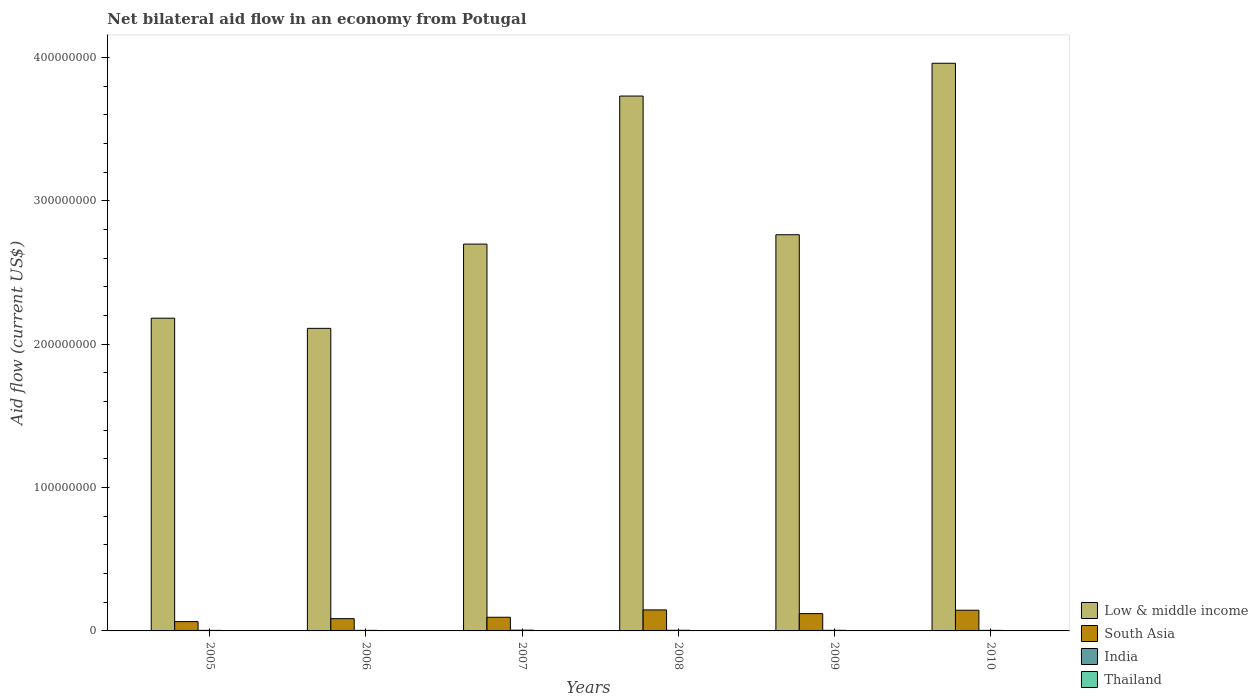How many bars are there on the 3rd tick from the left?
Ensure brevity in your answer.  4. Across all years, what is the maximum net bilateral aid flow in Low & middle income?
Your answer should be compact. 3.96e+08. In which year was the net bilateral aid flow in Low & middle income minimum?
Provide a succinct answer. 2006. What is the total net bilateral aid flow in Thailand in the graph?
Ensure brevity in your answer.  5.20e+05. What is the difference between the net bilateral aid flow in Thailand in 2005 and that in 2007?
Provide a short and direct response. 2.00e+04. What is the difference between the net bilateral aid flow in Thailand in 2010 and the net bilateral aid flow in India in 2006?
Give a very brief answer. -3.50e+05. What is the average net bilateral aid flow in Thailand per year?
Keep it short and to the point. 8.67e+04. In the year 2010, what is the difference between the net bilateral aid flow in South Asia and net bilateral aid flow in Thailand?
Give a very brief answer. 1.44e+07. What is the ratio of the net bilateral aid flow in India in 2007 to that in 2009?
Provide a short and direct response. 1.24. Is the net bilateral aid flow in Low & middle income in 2008 less than that in 2010?
Your answer should be very brief. Yes. What is the difference between the highest and the second highest net bilateral aid flow in India?
Make the answer very short. 8.00e+04. What is the difference between the highest and the lowest net bilateral aid flow in Low & middle income?
Keep it short and to the point. 1.85e+08. In how many years, is the net bilateral aid flow in South Asia greater than the average net bilateral aid flow in South Asia taken over all years?
Make the answer very short. 3. What does the 4th bar from the left in 2009 represents?
Your response must be concise. Thailand. What does the 1st bar from the right in 2007 represents?
Keep it short and to the point. Thailand. How many bars are there?
Your answer should be compact. 24. How many years are there in the graph?
Offer a very short reply. 6. What is the difference between two consecutive major ticks on the Y-axis?
Provide a short and direct response. 1.00e+08. Where does the legend appear in the graph?
Offer a terse response. Bottom right. How are the legend labels stacked?
Give a very brief answer. Vertical. What is the title of the graph?
Your answer should be very brief. Net bilateral aid flow in an economy from Potugal. What is the label or title of the X-axis?
Give a very brief answer. Years. What is the label or title of the Y-axis?
Give a very brief answer. Aid flow (current US$). What is the Aid flow (current US$) in Low & middle income in 2005?
Provide a succinct answer. 2.18e+08. What is the Aid flow (current US$) of South Asia in 2005?
Ensure brevity in your answer.  6.50e+06. What is the Aid flow (current US$) in India in 2005?
Provide a short and direct response. 3.90e+05. What is the Aid flow (current US$) of Thailand in 2005?
Keep it short and to the point. 6.00e+04. What is the Aid flow (current US$) of Low & middle income in 2006?
Offer a very short reply. 2.11e+08. What is the Aid flow (current US$) in South Asia in 2006?
Give a very brief answer. 8.56e+06. What is the Aid flow (current US$) of Low & middle income in 2007?
Offer a very short reply. 2.70e+08. What is the Aid flow (current US$) of South Asia in 2007?
Provide a short and direct response. 9.53e+06. What is the Aid flow (current US$) of India in 2007?
Offer a terse response. 5.20e+05. What is the Aid flow (current US$) of Low & middle income in 2008?
Offer a very short reply. 3.73e+08. What is the Aid flow (current US$) of South Asia in 2008?
Provide a succinct answer. 1.46e+07. What is the Aid flow (current US$) of Low & middle income in 2009?
Make the answer very short. 2.76e+08. What is the Aid flow (current US$) in South Asia in 2009?
Provide a short and direct response. 1.21e+07. What is the Aid flow (current US$) of India in 2009?
Give a very brief answer. 4.20e+05. What is the Aid flow (current US$) in Thailand in 2009?
Provide a succinct answer. 7.00e+04. What is the Aid flow (current US$) of Low & middle income in 2010?
Offer a very short reply. 3.96e+08. What is the Aid flow (current US$) of South Asia in 2010?
Give a very brief answer. 1.44e+07. Across all years, what is the maximum Aid flow (current US$) of Low & middle income?
Make the answer very short. 3.96e+08. Across all years, what is the maximum Aid flow (current US$) of South Asia?
Make the answer very short. 1.46e+07. Across all years, what is the maximum Aid flow (current US$) of India?
Make the answer very short. 5.20e+05. Across all years, what is the maximum Aid flow (current US$) of Thailand?
Offer a terse response. 2.20e+05. Across all years, what is the minimum Aid flow (current US$) of Low & middle income?
Make the answer very short. 2.11e+08. Across all years, what is the minimum Aid flow (current US$) in South Asia?
Offer a terse response. 6.50e+06. Across all years, what is the minimum Aid flow (current US$) of India?
Provide a short and direct response. 3.90e+05. What is the total Aid flow (current US$) in Low & middle income in the graph?
Offer a terse response. 1.74e+09. What is the total Aid flow (current US$) in South Asia in the graph?
Keep it short and to the point. 6.57e+07. What is the total Aid flow (current US$) of India in the graph?
Keep it short and to the point. 2.55e+06. What is the total Aid flow (current US$) of Thailand in the graph?
Your answer should be very brief. 5.20e+05. What is the difference between the Aid flow (current US$) of Low & middle income in 2005 and that in 2006?
Provide a succinct answer. 7.09e+06. What is the difference between the Aid flow (current US$) in South Asia in 2005 and that in 2006?
Your response must be concise. -2.06e+06. What is the difference between the Aid flow (current US$) of India in 2005 and that in 2006?
Your answer should be very brief. 0. What is the difference between the Aid flow (current US$) of Low & middle income in 2005 and that in 2007?
Provide a short and direct response. -5.17e+07. What is the difference between the Aid flow (current US$) in South Asia in 2005 and that in 2007?
Your answer should be compact. -3.03e+06. What is the difference between the Aid flow (current US$) in India in 2005 and that in 2007?
Offer a very short reply. -1.30e+05. What is the difference between the Aid flow (current US$) of Low & middle income in 2005 and that in 2008?
Your response must be concise. -1.55e+08. What is the difference between the Aid flow (current US$) in South Asia in 2005 and that in 2008?
Keep it short and to the point. -8.15e+06. What is the difference between the Aid flow (current US$) in India in 2005 and that in 2008?
Your answer should be very brief. -5.00e+04. What is the difference between the Aid flow (current US$) in Low & middle income in 2005 and that in 2009?
Your response must be concise. -5.82e+07. What is the difference between the Aid flow (current US$) in South Asia in 2005 and that in 2009?
Make the answer very short. -5.56e+06. What is the difference between the Aid flow (current US$) of India in 2005 and that in 2009?
Offer a terse response. -3.00e+04. What is the difference between the Aid flow (current US$) in Low & middle income in 2005 and that in 2010?
Your answer should be very brief. -1.78e+08. What is the difference between the Aid flow (current US$) of South Asia in 2005 and that in 2010?
Your answer should be very brief. -7.94e+06. What is the difference between the Aid flow (current US$) in India in 2005 and that in 2010?
Your answer should be very brief. 0. What is the difference between the Aid flow (current US$) in Thailand in 2005 and that in 2010?
Offer a very short reply. 2.00e+04. What is the difference between the Aid flow (current US$) in Low & middle income in 2006 and that in 2007?
Your answer should be compact. -5.88e+07. What is the difference between the Aid flow (current US$) of South Asia in 2006 and that in 2007?
Your answer should be compact. -9.70e+05. What is the difference between the Aid flow (current US$) of Thailand in 2006 and that in 2007?
Provide a succinct answer. 1.80e+05. What is the difference between the Aid flow (current US$) of Low & middle income in 2006 and that in 2008?
Keep it short and to the point. -1.62e+08. What is the difference between the Aid flow (current US$) of South Asia in 2006 and that in 2008?
Your response must be concise. -6.09e+06. What is the difference between the Aid flow (current US$) of Thailand in 2006 and that in 2008?
Your response must be concise. 1.30e+05. What is the difference between the Aid flow (current US$) in Low & middle income in 2006 and that in 2009?
Offer a terse response. -6.53e+07. What is the difference between the Aid flow (current US$) of South Asia in 2006 and that in 2009?
Offer a terse response. -3.50e+06. What is the difference between the Aid flow (current US$) in Low & middle income in 2006 and that in 2010?
Your answer should be compact. -1.85e+08. What is the difference between the Aid flow (current US$) of South Asia in 2006 and that in 2010?
Provide a succinct answer. -5.88e+06. What is the difference between the Aid flow (current US$) in India in 2006 and that in 2010?
Offer a terse response. 0. What is the difference between the Aid flow (current US$) of Thailand in 2006 and that in 2010?
Ensure brevity in your answer.  1.80e+05. What is the difference between the Aid flow (current US$) of Low & middle income in 2007 and that in 2008?
Keep it short and to the point. -1.03e+08. What is the difference between the Aid flow (current US$) in South Asia in 2007 and that in 2008?
Provide a short and direct response. -5.12e+06. What is the difference between the Aid flow (current US$) in India in 2007 and that in 2008?
Make the answer very short. 8.00e+04. What is the difference between the Aid flow (current US$) in Low & middle income in 2007 and that in 2009?
Ensure brevity in your answer.  -6.52e+06. What is the difference between the Aid flow (current US$) of South Asia in 2007 and that in 2009?
Provide a succinct answer. -2.53e+06. What is the difference between the Aid flow (current US$) of Thailand in 2007 and that in 2009?
Make the answer very short. -3.00e+04. What is the difference between the Aid flow (current US$) of Low & middle income in 2007 and that in 2010?
Provide a succinct answer. -1.26e+08. What is the difference between the Aid flow (current US$) of South Asia in 2007 and that in 2010?
Provide a short and direct response. -4.91e+06. What is the difference between the Aid flow (current US$) in Low & middle income in 2008 and that in 2009?
Your answer should be compact. 9.67e+07. What is the difference between the Aid flow (current US$) in South Asia in 2008 and that in 2009?
Provide a succinct answer. 2.59e+06. What is the difference between the Aid flow (current US$) in Thailand in 2008 and that in 2009?
Ensure brevity in your answer.  2.00e+04. What is the difference between the Aid flow (current US$) in Low & middle income in 2008 and that in 2010?
Provide a succinct answer. -2.29e+07. What is the difference between the Aid flow (current US$) in South Asia in 2008 and that in 2010?
Offer a very short reply. 2.10e+05. What is the difference between the Aid flow (current US$) in India in 2008 and that in 2010?
Ensure brevity in your answer.  5.00e+04. What is the difference between the Aid flow (current US$) in Low & middle income in 2009 and that in 2010?
Offer a terse response. -1.20e+08. What is the difference between the Aid flow (current US$) of South Asia in 2009 and that in 2010?
Your answer should be very brief. -2.38e+06. What is the difference between the Aid flow (current US$) of India in 2009 and that in 2010?
Make the answer very short. 3.00e+04. What is the difference between the Aid flow (current US$) in Thailand in 2009 and that in 2010?
Give a very brief answer. 3.00e+04. What is the difference between the Aid flow (current US$) in Low & middle income in 2005 and the Aid flow (current US$) in South Asia in 2006?
Your response must be concise. 2.10e+08. What is the difference between the Aid flow (current US$) in Low & middle income in 2005 and the Aid flow (current US$) in India in 2006?
Your answer should be compact. 2.18e+08. What is the difference between the Aid flow (current US$) of Low & middle income in 2005 and the Aid flow (current US$) of Thailand in 2006?
Offer a terse response. 2.18e+08. What is the difference between the Aid flow (current US$) in South Asia in 2005 and the Aid flow (current US$) in India in 2006?
Make the answer very short. 6.11e+06. What is the difference between the Aid flow (current US$) in South Asia in 2005 and the Aid flow (current US$) in Thailand in 2006?
Your answer should be compact. 6.28e+06. What is the difference between the Aid flow (current US$) of India in 2005 and the Aid flow (current US$) of Thailand in 2006?
Offer a terse response. 1.70e+05. What is the difference between the Aid flow (current US$) of Low & middle income in 2005 and the Aid flow (current US$) of South Asia in 2007?
Give a very brief answer. 2.09e+08. What is the difference between the Aid flow (current US$) in Low & middle income in 2005 and the Aid flow (current US$) in India in 2007?
Provide a short and direct response. 2.18e+08. What is the difference between the Aid flow (current US$) in Low & middle income in 2005 and the Aid flow (current US$) in Thailand in 2007?
Offer a terse response. 2.18e+08. What is the difference between the Aid flow (current US$) in South Asia in 2005 and the Aid flow (current US$) in India in 2007?
Your response must be concise. 5.98e+06. What is the difference between the Aid flow (current US$) of South Asia in 2005 and the Aid flow (current US$) of Thailand in 2007?
Provide a succinct answer. 6.46e+06. What is the difference between the Aid flow (current US$) in India in 2005 and the Aid flow (current US$) in Thailand in 2007?
Give a very brief answer. 3.50e+05. What is the difference between the Aid flow (current US$) of Low & middle income in 2005 and the Aid flow (current US$) of South Asia in 2008?
Provide a succinct answer. 2.03e+08. What is the difference between the Aid flow (current US$) in Low & middle income in 2005 and the Aid flow (current US$) in India in 2008?
Provide a short and direct response. 2.18e+08. What is the difference between the Aid flow (current US$) in Low & middle income in 2005 and the Aid flow (current US$) in Thailand in 2008?
Keep it short and to the point. 2.18e+08. What is the difference between the Aid flow (current US$) of South Asia in 2005 and the Aid flow (current US$) of India in 2008?
Ensure brevity in your answer.  6.06e+06. What is the difference between the Aid flow (current US$) of South Asia in 2005 and the Aid flow (current US$) of Thailand in 2008?
Offer a very short reply. 6.41e+06. What is the difference between the Aid flow (current US$) in Low & middle income in 2005 and the Aid flow (current US$) in South Asia in 2009?
Provide a succinct answer. 2.06e+08. What is the difference between the Aid flow (current US$) in Low & middle income in 2005 and the Aid flow (current US$) in India in 2009?
Give a very brief answer. 2.18e+08. What is the difference between the Aid flow (current US$) in Low & middle income in 2005 and the Aid flow (current US$) in Thailand in 2009?
Provide a short and direct response. 2.18e+08. What is the difference between the Aid flow (current US$) in South Asia in 2005 and the Aid flow (current US$) in India in 2009?
Provide a succinct answer. 6.08e+06. What is the difference between the Aid flow (current US$) of South Asia in 2005 and the Aid flow (current US$) of Thailand in 2009?
Provide a short and direct response. 6.43e+06. What is the difference between the Aid flow (current US$) in India in 2005 and the Aid flow (current US$) in Thailand in 2009?
Your response must be concise. 3.20e+05. What is the difference between the Aid flow (current US$) in Low & middle income in 2005 and the Aid flow (current US$) in South Asia in 2010?
Keep it short and to the point. 2.04e+08. What is the difference between the Aid flow (current US$) of Low & middle income in 2005 and the Aid flow (current US$) of India in 2010?
Provide a short and direct response. 2.18e+08. What is the difference between the Aid flow (current US$) in Low & middle income in 2005 and the Aid flow (current US$) in Thailand in 2010?
Keep it short and to the point. 2.18e+08. What is the difference between the Aid flow (current US$) in South Asia in 2005 and the Aid flow (current US$) in India in 2010?
Ensure brevity in your answer.  6.11e+06. What is the difference between the Aid flow (current US$) in South Asia in 2005 and the Aid flow (current US$) in Thailand in 2010?
Provide a succinct answer. 6.46e+06. What is the difference between the Aid flow (current US$) in India in 2005 and the Aid flow (current US$) in Thailand in 2010?
Your answer should be very brief. 3.50e+05. What is the difference between the Aid flow (current US$) in Low & middle income in 2006 and the Aid flow (current US$) in South Asia in 2007?
Provide a short and direct response. 2.02e+08. What is the difference between the Aid flow (current US$) in Low & middle income in 2006 and the Aid flow (current US$) in India in 2007?
Give a very brief answer. 2.11e+08. What is the difference between the Aid flow (current US$) in Low & middle income in 2006 and the Aid flow (current US$) in Thailand in 2007?
Keep it short and to the point. 2.11e+08. What is the difference between the Aid flow (current US$) of South Asia in 2006 and the Aid flow (current US$) of India in 2007?
Your answer should be compact. 8.04e+06. What is the difference between the Aid flow (current US$) of South Asia in 2006 and the Aid flow (current US$) of Thailand in 2007?
Provide a short and direct response. 8.52e+06. What is the difference between the Aid flow (current US$) in Low & middle income in 2006 and the Aid flow (current US$) in South Asia in 2008?
Offer a terse response. 1.96e+08. What is the difference between the Aid flow (current US$) in Low & middle income in 2006 and the Aid flow (current US$) in India in 2008?
Offer a terse response. 2.11e+08. What is the difference between the Aid flow (current US$) of Low & middle income in 2006 and the Aid flow (current US$) of Thailand in 2008?
Your answer should be compact. 2.11e+08. What is the difference between the Aid flow (current US$) in South Asia in 2006 and the Aid flow (current US$) in India in 2008?
Offer a terse response. 8.12e+06. What is the difference between the Aid flow (current US$) in South Asia in 2006 and the Aid flow (current US$) in Thailand in 2008?
Your answer should be compact. 8.47e+06. What is the difference between the Aid flow (current US$) of Low & middle income in 2006 and the Aid flow (current US$) of South Asia in 2009?
Provide a short and direct response. 1.99e+08. What is the difference between the Aid flow (current US$) of Low & middle income in 2006 and the Aid flow (current US$) of India in 2009?
Ensure brevity in your answer.  2.11e+08. What is the difference between the Aid flow (current US$) in Low & middle income in 2006 and the Aid flow (current US$) in Thailand in 2009?
Make the answer very short. 2.11e+08. What is the difference between the Aid flow (current US$) of South Asia in 2006 and the Aid flow (current US$) of India in 2009?
Give a very brief answer. 8.14e+06. What is the difference between the Aid flow (current US$) of South Asia in 2006 and the Aid flow (current US$) of Thailand in 2009?
Offer a very short reply. 8.49e+06. What is the difference between the Aid flow (current US$) in India in 2006 and the Aid flow (current US$) in Thailand in 2009?
Offer a very short reply. 3.20e+05. What is the difference between the Aid flow (current US$) of Low & middle income in 2006 and the Aid flow (current US$) of South Asia in 2010?
Your answer should be compact. 1.97e+08. What is the difference between the Aid flow (current US$) in Low & middle income in 2006 and the Aid flow (current US$) in India in 2010?
Provide a succinct answer. 2.11e+08. What is the difference between the Aid flow (current US$) of Low & middle income in 2006 and the Aid flow (current US$) of Thailand in 2010?
Make the answer very short. 2.11e+08. What is the difference between the Aid flow (current US$) of South Asia in 2006 and the Aid flow (current US$) of India in 2010?
Offer a terse response. 8.17e+06. What is the difference between the Aid flow (current US$) of South Asia in 2006 and the Aid flow (current US$) of Thailand in 2010?
Keep it short and to the point. 8.52e+06. What is the difference between the Aid flow (current US$) of Low & middle income in 2007 and the Aid flow (current US$) of South Asia in 2008?
Ensure brevity in your answer.  2.55e+08. What is the difference between the Aid flow (current US$) in Low & middle income in 2007 and the Aid flow (current US$) in India in 2008?
Make the answer very short. 2.69e+08. What is the difference between the Aid flow (current US$) of Low & middle income in 2007 and the Aid flow (current US$) of Thailand in 2008?
Your response must be concise. 2.70e+08. What is the difference between the Aid flow (current US$) in South Asia in 2007 and the Aid flow (current US$) in India in 2008?
Give a very brief answer. 9.09e+06. What is the difference between the Aid flow (current US$) of South Asia in 2007 and the Aid flow (current US$) of Thailand in 2008?
Give a very brief answer. 9.44e+06. What is the difference between the Aid flow (current US$) of India in 2007 and the Aid flow (current US$) of Thailand in 2008?
Your answer should be very brief. 4.30e+05. What is the difference between the Aid flow (current US$) in Low & middle income in 2007 and the Aid flow (current US$) in South Asia in 2009?
Keep it short and to the point. 2.58e+08. What is the difference between the Aid flow (current US$) in Low & middle income in 2007 and the Aid flow (current US$) in India in 2009?
Ensure brevity in your answer.  2.69e+08. What is the difference between the Aid flow (current US$) of Low & middle income in 2007 and the Aid flow (current US$) of Thailand in 2009?
Make the answer very short. 2.70e+08. What is the difference between the Aid flow (current US$) in South Asia in 2007 and the Aid flow (current US$) in India in 2009?
Keep it short and to the point. 9.11e+06. What is the difference between the Aid flow (current US$) in South Asia in 2007 and the Aid flow (current US$) in Thailand in 2009?
Provide a succinct answer. 9.46e+06. What is the difference between the Aid flow (current US$) of India in 2007 and the Aid flow (current US$) of Thailand in 2009?
Your answer should be very brief. 4.50e+05. What is the difference between the Aid flow (current US$) of Low & middle income in 2007 and the Aid flow (current US$) of South Asia in 2010?
Offer a very short reply. 2.55e+08. What is the difference between the Aid flow (current US$) of Low & middle income in 2007 and the Aid flow (current US$) of India in 2010?
Provide a succinct answer. 2.69e+08. What is the difference between the Aid flow (current US$) of Low & middle income in 2007 and the Aid flow (current US$) of Thailand in 2010?
Your answer should be compact. 2.70e+08. What is the difference between the Aid flow (current US$) in South Asia in 2007 and the Aid flow (current US$) in India in 2010?
Give a very brief answer. 9.14e+06. What is the difference between the Aid flow (current US$) in South Asia in 2007 and the Aid flow (current US$) in Thailand in 2010?
Offer a terse response. 9.49e+06. What is the difference between the Aid flow (current US$) of India in 2007 and the Aid flow (current US$) of Thailand in 2010?
Provide a short and direct response. 4.80e+05. What is the difference between the Aid flow (current US$) of Low & middle income in 2008 and the Aid flow (current US$) of South Asia in 2009?
Provide a short and direct response. 3.61e+08. What is the difference between the Aid flow (current US$) in Low & middle income in 2008 and the Aid flow (current US$) in India in 2009?
Make the answer very short. 3.73e+08. What is the difference between the Aid flow (current US$) in Low & middle income in 2008 and the Aid flow (current US$) in Thailand in 2009?
Your response must be concise. 3.73e+08. What is the difference between the Aid flow (current US$) in South Asia in 2008 and the Aid flow (current US$) in India in 2009?
Ensure brevity in your answer.  1.42e+07. What is the difference between the Aid flow (current US$) in South Asia in 2008 and the Aid flow (current US$) in Thailand in 2009?
Provide a succinct answer. 1.46e+07. What is the difference between the Aid flow (current US$) of Low & middle income in 2008 and the Aid flow (current US$) of South Asia in 2010?
Give a very brief answer. 3.59e+08. What is the difference between the Aid flow (current US$) in Low & middle income in 2008 and the Aid flow (current US$) in India in 2010?
Provide a short and direct response. 3.73e+08. What is the difference between the Aid flow (current US$) in Low & middle income in 2008 and the Aid flow (current US$) in Thailand in 2010?
Provide a short and direct response. 3.73e+08. What is the difference between the Aid flow (current US$) of South Asia in 2008 and the Aid flow (current US$) of India in 2010?
Provide a short and direct response. 1.43e+07. What is the difference between the Aid flow (current US$) in South Asia in 2008 and the Aid flow (current US$) in Thailand in 2010?
Offer a terse response. 1.46e+07. What is the difference between the Aid flow (current US$) of Low & middle income in 2009 and the Aid flow (current US$) of South Asia in 2010?
Offer a terse response. 2.62e+08. What is the difference between the Aid flow (current US$) of Low & middle income in 2009 and the Aid flow (current US$) of India in 2010?
Your answer should be compact. 2.76e+08. What is the difference between the Aid flow (current US$) of Low & middle income in 2009 and the Aid flow (current US$) of Thailand in 2010?
Give a very brief answer. 2.76e+08. What is the difference between the Aid flow (current US$) in South Asia in 2009 and the Aid flow (current US$) in India in 2010?
Your answer should be compact. 1.17e+07. What is the difference between the Aid flow (current US$) of South Asia in 2009 and the Aid flow (current US$) of Thailand in 2010?
Give a very brief answer. 1.20e+07. What is the average Aid flow (current US$) in Low & middle income per year?
Provide a short and direct response. 2.91e+08. What is the average Aid flow (current US$) in South Asia per year?
Your answer should be very brief. 1.10e+07. What is the average Aid flow (current US$) of India per year?
Your answer should be very brief. 4.25e+05. What is the average Aid flow (current US$) in Thailand per year?
Your answer should be compact. 8.67e+04. In the year 2005, what is the difference between the Aid flow (current US$) of Low & middle income and Aid flow (current US$) of South Asia?
Make the answer very short. 2.12e+08. In the year 2005, what is the difference between the Aid flow (current US$) in Low & middle income and Aid flow (current US$) in India?
Keep it short and to the point. 2.18e+08. In the year 2005, what is the difference between the Aid flow (current US$) in Low & middle income and Aid flow (current US$) in Thailand?
Keep it short and to the point. 2.18e+08. In the year 2005, what is the difference between the Aid flow (current US$) of South Asia and Aid flow (current US$) of India?
Your answer should be compact. 6.11e+06. In the year 2005, what is the difference between the Aid flow (current US$) of South Asia and Aid flow (current US$) of Thailand?
Provide a short and direct response. 6.44e+06. In the year 2006, what is the difference between the Aid flow (current US$) in Low & middle income and Aid flow (current US$) in South Asia?
Your response must be concise. 2.02e+08. In the year 2006, what is the difference between the Aid flow (current US$) of Low & middle income and Aid flow (current US$) of India?
Ensure brevity in your answer.  2.11e+08. In the year 2006, what is the difference between the Aid flow (current US$) in Low & middle income and Aid flow (current US$) in Thailand?
Offer a very short reply. 2.11e+08. In the year 2006, what is the difference between the Aid flow (current US$) of South Asia and Aid flow (current US$) of India?
Provide a short and direct response. 8.17e+06. In the year 2006, what is the difference between the Aid flow (current US$) in South Asia and Aid flow (current US$) in Thailand?
Your response must be concise. 8.34e+06. In the year 2007, what is the difference between the Aid flow (current US$) of Low & middle income and Aid flow (current US$) of South Asia?
Keep it short and to the point. 2.60e+08. In the year 2007, what is the difference between the Aid flow (current US$) of Low & middle income and Aid flow (current US$) of India?
Ensure brevity in your answer.  2.69e+08. In the year 2007, what is the difference between the Aid flow (current US$) of Low & middle income and Aid flow (current US$) of Thailand?
Your response must be concise. 2.70e+08. In the year 2007, what is the difference between the Aid flow (current US$) of South Asia and Aid flow (current US$) of India?
Give a very brief answer. 9.01e+06. In the year 2007, what is the difference between the Aid flow (current US$) of South Asia and Aid flow (current US$) of Thailand?
Provide a short and direct response. 9.49e+06. In the year 2007, what is the difference between the Aid flow (current US$) in India and Aid flow (current US$) in Thailand?
Keep it short and to the point. 4.80e+05. In the year 2008, what is the difference between the Aid flow (current US$) of Low & middle income and Aid flow (current US$) of South Asia?
Offer a terse response. 3.58e+08. In the year 2008, what is the difference between the Aid flow (current US$) of Low & middle income and Aid flow (current US$) of India?
Offer a very short reply. 3.73e+08. In the year 2008, what is the difference between the Aid flow (current US$) in Low & middle income and Aid flow (current US$) in Thailand?
Provide a succinct answer. 3.73e+08. In the year 2008, what is the difference between the Aid flow (current US$) of South Asia and Aid flow (current US$) of India?
Offer a very short reply. 1.42e+07. In the year 2008, what is the difference between the Aid flow (current US$) in South Asia and Aid flow (current US$) in Thailand?
Make the answer very short. 1.46e+07. In the year 2009, what is the difference between the Aid flow (current US$) in Low & middle income and Aid flow (current US$) in South Asia?
Provide a short and direct response. 2.64e+08. In the year 2009, what is the difference between the Aid flow (current US$) in Low & middle income and Aid flow (current US$) in India?
Provide a short and direct response. 2.76e+08. In the year 2009, what is the difference between the Aid flow (current US$) in Low & middle income and Aid flow (current US$) in Thailand?
Keep it short and to the point. 2.76e+08. In the year 2009, what is the difference between the Aid flow (current US$) of South Asia and Aid flow (current US$) of India?
Give a very brief answer. 1.16e+07. In the year 2009, what is the difference between the Aid flow (current US$) of South Asia and Aid flow (current US$) of Thailand?
Keep it short and to the point. 1.20e+07. In the year 2010, what is the difference between the Aid flow (current US$) of Low & middle income and Aid flow (current US$) of South Asia?
Your answer should be very brief. 3.82e+08. In the year 2010, what is the difference between the Aid flow (current US$) of Low & middle income and Aid flow (current US$) of India?
Give a very brief answer. 3.96e+08. In the year 2010, what is the difference between the Aid flow (current US$) of Low & middle income and Aid flow (current US$) of Thailand?
Ensure brevity in your answer.  3.96e+08. In the year 2010, what is the difference between the Aid flow (current US$) in South Asia and Aid flow (current US$) in India?
Make the answer very short. 1.40e+07. In the year 2010, what is the difference between the Aid flow (current US$) in South Asia and Aid flow (current US$) in Thailand?
Your response must be concise. 1.44e+07. In the year 2010, what is the difference between the Aid flow (current US$) in India and Aid flow (current US$) in Thailand?
Your response must be concise. 3.50e+05. What is the ratio of the Aid flow (current US$) of Low & middle income in 2005 to that in 2006?
Keep it short and to the point. 1.03. What is the ratio of the Aid flow (current US$) of South Asia in 2005 to that in 2006?
Your answer should be compact. 0.76. What is the ratio of the Aid flow (current US$) of India in 2005 to that in 2006?
Give a very brief answer. 1. What is the ratio of the Aid flow (current US$) in Thailand in 2005 to that in 2006?
Keep it short and to the point. 0.27. What is the ratio of the Aid flow (current US$) in Low & middle income in 2005 to that in 2007?
Your response must be concise. 0.81. What is the ratio of the Aid flow (current US$) in South Asia in 2005 to that in 2007?
Offer a very short reply. 0.68. What is the ratio of the Aid flow (current US$) of Low & middle income in 2005 to that in 2008?
Provide a succinct answer. 0.58. What is the ratio of the Aid flow (current US$) of South Asia in 2005 to that in 2008?
Offer a very short reply. 0.44. What is the ratio of the Aid flow (current US$) of India in 2005 to that in 2008?
Provide a succinct answer. 0.89. What is the ratio of the Aid flow (current US$) of Low & middle income in 2005 to that in 2009?
Offer a terse response. 0.79. What is the ratio of the Aid flow (current US$) in South Asia in 2005 to that in 2009?
Your response must be concise. 0.54. What is the ratio of the Aid flow (current US$) in Low & middle income in 2005 to that in 2010?
Offer a very short reply. 0.55. What is the ratio of the Aid flow (current US$) in South Asia in 2005 to that in 2010?
Provide a short and direct response. 0.45. What is the ratio of the Aid flow (current US$) of Thailand in 2005 to that in 2010?
Your response must be concise. 1.5. What is the ratio of the Aid flow (current US$) of Low & middle income in 2006 to that in 2007?
Ensure brevity in your answer.  0.78. What is the ratio of the Aid flow (current US$) of South Asia in 2006 to that in 2007?
Ensure brevity in your answer.  0.9. What is the ratio of the Aid flow (current US$) in Thailand in 2006 to that in 2007?
Keep it short and to the point. 5.5. What is the ratio of the Aid flow (current US$) of Low & middle income in 2006 to that in 2008?
Offer a terse response. 0.57. What is the ratio of the Aid flow (current US$) of South Asia in 2006 to that in 2008?
Your answer should be compact. 0.58. What is the ratio of the Aid flow (current US$) in India in 2006 to that in 2008?
Your answer should be very brief. 0.89. What is the ratio of the Aid flow (current US$) of Thailand in 2006 to that in 2008?
Provide a succinct answer. 2.44. What is the ratio of the Aid flow (current US$) of Low & middle income in 2006 to that in 2009?
Offer a terse response. 0.76. What is the ratio of the Aid flow (current US$) of South Asia in 2006 to that in 2009?
Offer a very short reply. 0.71. What is the ratio of the Aid flow (current US$) of Thailand in 2006 to that in 2009?
Offer a very short reply. 3.14. What is the ratio of the Aid flow (current US$) of Low & middle income in 2006 to that in 2010?
Provide a succinct answer. 0.53. What is the ratio of the Aid flow (current US$) in South Asia in 2006 to that in 2010?
Offer a terse response. 0.59. What is the ratio of the Aid flow (current US$) of India in 2006 to that in 2010?
Keep it short and to the point. 1. What is the ratio of the Aid flow (current US$) of Low & middle income in 2007 to that in 2008?
Provide a short and direct response. 0.72. What is the ratio of the Aid flow (current US$) of South Asia in 2007 to that in 2008?
Your answer should be very brief. 0.65. What is the ratio of the Aid flow (current US$) of India in 2007 to that in 2008?
Your answer should be very brief. 1.18. What is the ratio of the Aid flow (current US$) of Thailand in 2007 to that in 2008?
Ensure brevity in your answer.  0.44. What is the ratio of the Aid flow (current US$) in Low & middle income in 2007 to that in 2009?
Your answer should be compact. 0.98. What is the ratio of the Aid flow (current US$) in South Asia in 2007 to that in 2009?
Ensure brevity in your answer.  0.79. What is the ratio of the Aid flow (current US$) in India in 2007 to that in 2009?
Your answer should be very brief. 1.24. What is the ratio of the Aid flow (current US$) of Thailand in 2007 to that in 2009?
Offer a terse response. 0.57. What is the ratio of the Aid flow (current US$) in Low & middle income in 2007 to that in 2010?
Make the answer very short. 0.68. What is the ratio of the Aid flow (current US$) of South Asia in 2007 to that in 2010?
Keep it short and to the point. 0.66. What is the ratio of the Aid flow (current US$) in Low & middle income in 2008 to that in 2009?
Give a very brief answer. 1.35. What is the ratio of the Aid flow (current US$) in South Asia in 2008 to that in 2009?
Provide a succinct answer. 1.21. What is the ratio of the Aid flow (current US$) of India in 2008 to that in 2009?
Make the answer very short. 1.05. What is the ratio of the Aid flow (current US$) of Thailand in 2008 to that in 2009?
Keep it short and to the point. 1.29. What is the ratio of the Aid flow (current US$) of Low & middle income in 2008 to that in 2010?
Keep it short and to the point. 0.94. What is the ratio of the Aid flow (current US$) of South Asia in 2008 to that in 2010?
Give a very brief answer. 1.01. What is the ratio of the Aid flow (current US$) in India in 2008 to that in 2010?
Provide a short and direct response. 1.13. What is the ratio of the Aid flow (current US$) of Thailand in 2008 to that in 2010?
Make the answer very short. 2.25. What is the ratio of the Aid flow (current US$) in Low & middle income in 2009 to that in 2010?
Your answer should be very brief. 0.7. What is the ratio of the Aid flow (current US$) of South Asia in 2009 to that in 2010?
Ensure brevity in your answer.  0.84. What is the difference between the highest and the second highest Aid flow (current US$) in Low & middle income?
Provide a succinct answer. 2.29e+07. What is the difference between the highest and the second highest Aid flow (current US$) in South Asia?
Make the answer very short. 2.10e+05. What is the difference between the highest and the second highest Aid flow (current US$) of Thailand?
Offer a very short reply. 1.30e+05. What is the difference between the highest and the lowest Aid flow (current US$) of Low & middle income?
Make the answer very short. 1.85e+08. What is the difference between the highest and the lowest Aid flow (current US$) in South Asia?
Keep it short and to the point. 8.15e+06. What is the difference between the highest and the lowest Aid flow (current US$) in Thailand?
Make the answer very short. 1.80e+05. 